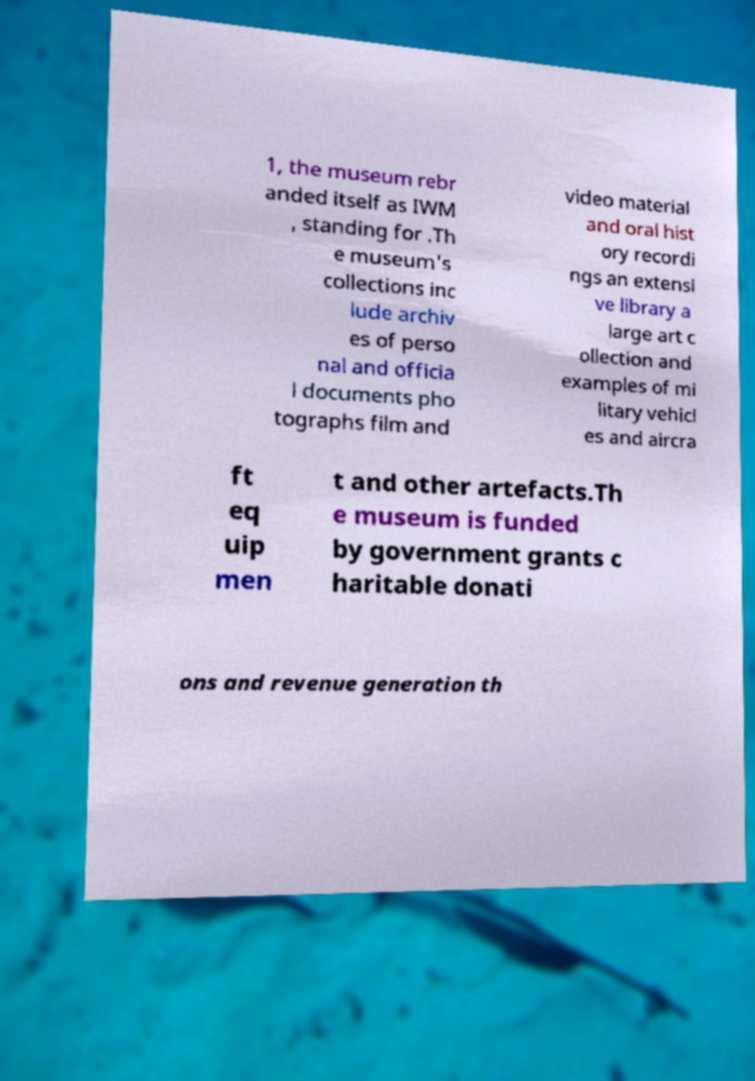I need the written content from this picture converted into text. Can you do that? 1, the museum rebr anded itself as IWM , standing for .Th e museum's collections inc lude archiv es of perso nal and officia l documents pho tographs film and video material and oral hist ory recordi ngs an extensi ve library a large art c ollection and examples of mi litary vehicl es and aircra ft eq uip men t and other artefacts.Th e museum is funded by government grants c haritable donati ons and revenue generation th 